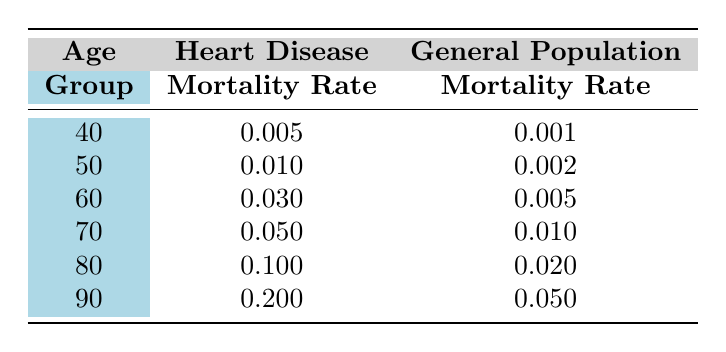What is the heart disease mortality rate for individuals aged 60? From the table, the heart disease mortality rate for the age group of 60 is 0.030.
Answer: 0.030 How does the heart disease mortality rate for age 70 compare to that of the general population in the same age group? For age 70, the heart disease mortality rate is 0.050, while the general population’s rate is 0.010. This shows that heart disease patients are five times more likely to die compared to the general population at this age.
Answer: Five times more likely What is the difference in mortality rates between heart disease patients and the general population at age 80? The heart disease mortality rate at age 80 is 0.100, and the general population's rate is 0.020. The difference is 0.100 - 0.020 = 0.080.
Answer: 0.080 Is the mortality rate for heart disease patients at age 50 higher than that of the general population? Yes, the heart disease mortality rate at age 50 is 0.010, and the general population's rate is 0.002, indicating that heart disease patients have a higher mortality rate.
Answer: Yes What is the average mortality rate for heart disease patients across all age groups? The mortality rates for heart disease patients are 0.005, 0.010, 0.030, 0.050, 0.100, and 0.200. Adding these gives a total of 0.005 + 0.010 + 0.030 + 0.050 + 0.100 + 0.200 = 0.395. There are 6 age groups, so the average is 0.395/6 = 0.0658333, approximately 0.066.
Answer: 0.066 At what age does the mortality rate for heart disease patients first exceed 0.1? The age group of 80 has the first heart disease mortality rate of 0.100. All previous age groups have lower rates, indicating this is the first occurrence.
Answer: 80 